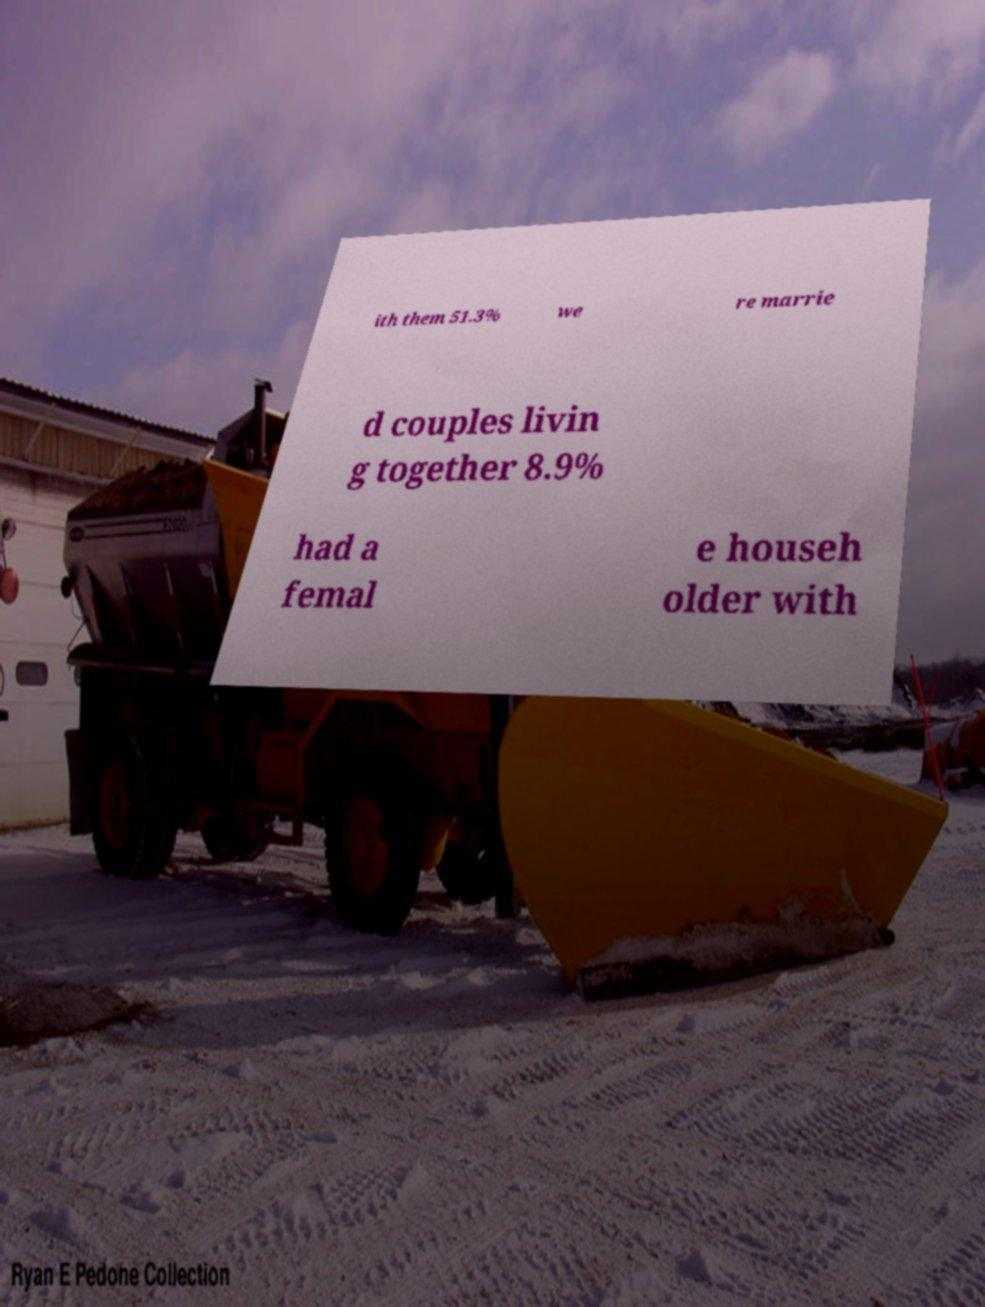For documentation purposes, I need the text within this image transcribed. Could you provide that? ith them 51.3% we re marrie d couples livin g together 8.9% had a femal e househ older with 